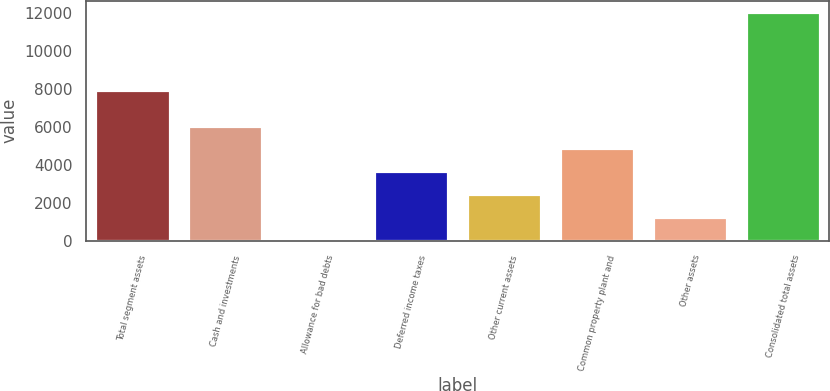Convert chart to OTSL. <chart><loc_0><loc_0><loc_500><loc_500><bar_chart><fcel>Total segment assets<fcel>Cash and investments<fcel>Allowance for bad debts<fcel>Deferred income taxes<fcel>Other current assets<fcel>Common property plant and<fcel>Other assets<fcel>Consolidated total assets<nl><fcel>7959<fcel>6058.5<fcel>74<fcel>3664.7<fcel>2467.8<fcel>4861.6<fcel>1270.9<fcel>12043<nl></chart> 